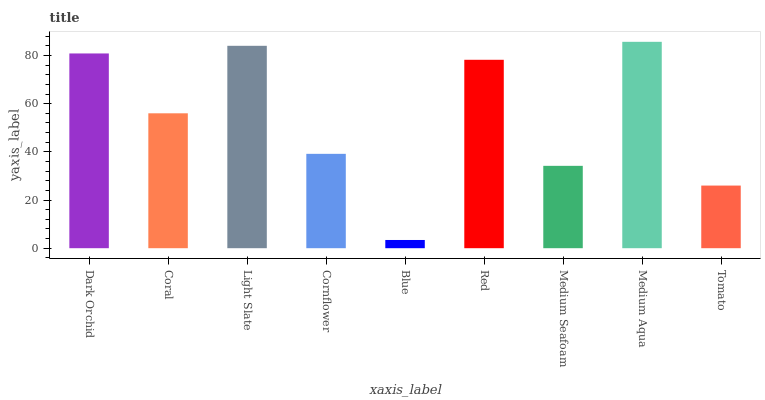Is Blue the minimum?
Answer yes or no. Yes. Is Medium Aqua the maximum?
Answer yes or no. Yes. Is Coral the minimum?
Answer yes or no. No. Is Coral the maximum?
Answer yes or no. No. Is Dark Orchid greater than Coral?
Answer yes or no. Yes. Is Coral less than Dark Orchid?
Answer yes or no. Yes. Is Coral greater than Dark Orchid?
Answer yes or no. No. Is Dark Orchid less than Coral?
Answer yes or no. No. Is Coral the high median?
Answer yes or no. Yes. Is Coral the low median?
Answer yes or no. Yes. Is Medium Seafoam the high median?
Answer yes or no. No. Is Blue the low median?
Answer yes or no. No. 